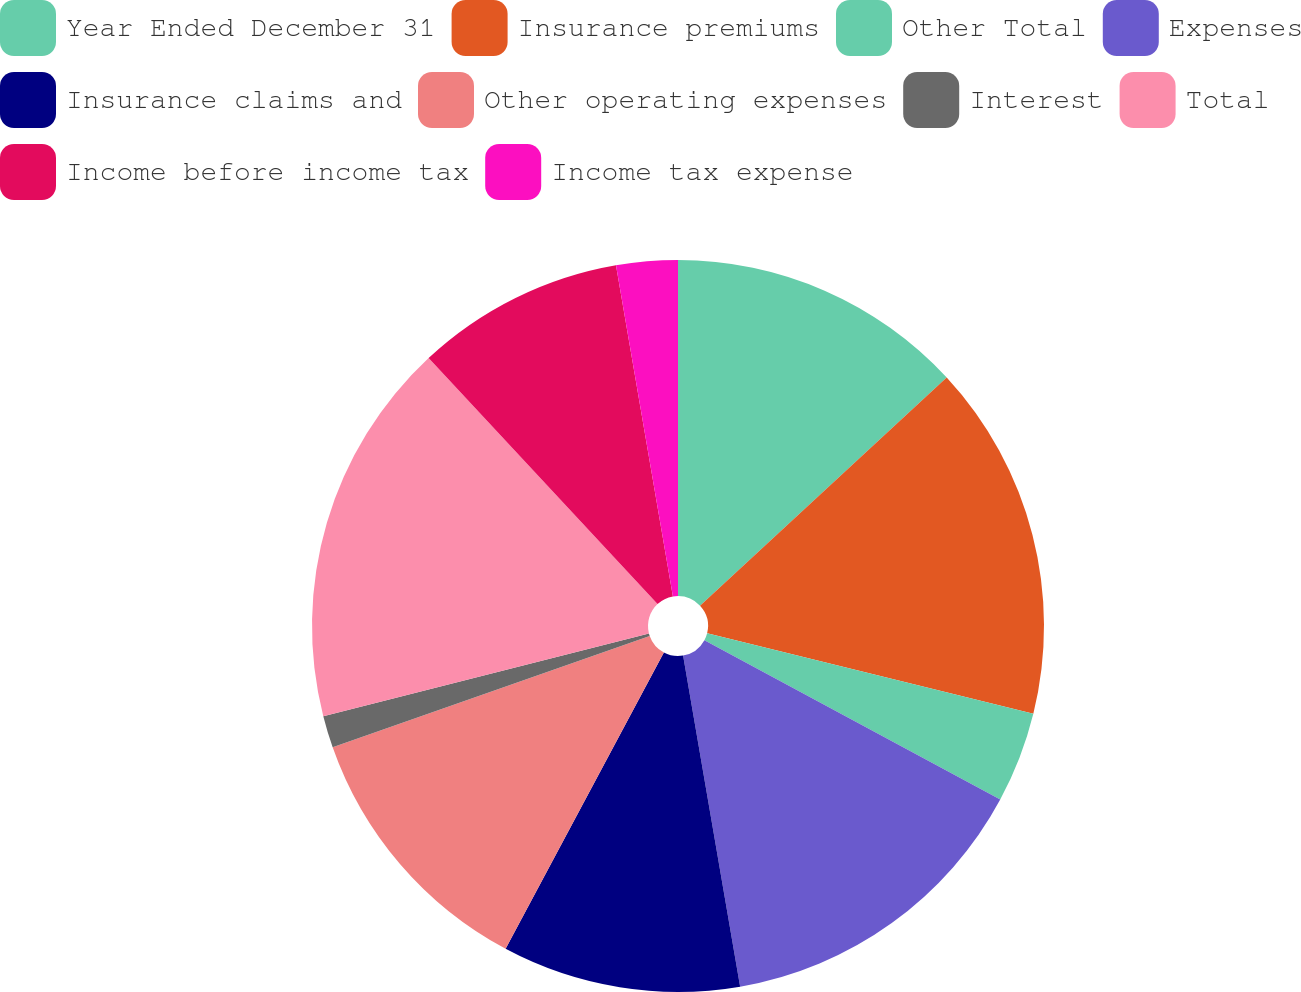Convert chart to OTSL. <chart><loc_0><loc_0><loc_500><loc_500><pie_chart><fcel>Year Ended December 31<fcel>Insurance premiums<fcel>Other Total<fcel>Expenses<fcel>Insurance claims and<fcel>Other operating expenses<fcel>Interest<fcel>Total<fcel>Income before income tax<fcel>Income tax expense<nl><fcel>13.12%<fcel>15.73%<fcel>4.01%<fcel>14.42%<fcel>10.52%<fcel>11.82%<fcel>1.41%<fcel>17.03%<fcel>9.22%<fcel>2.71%<nl></chart> 